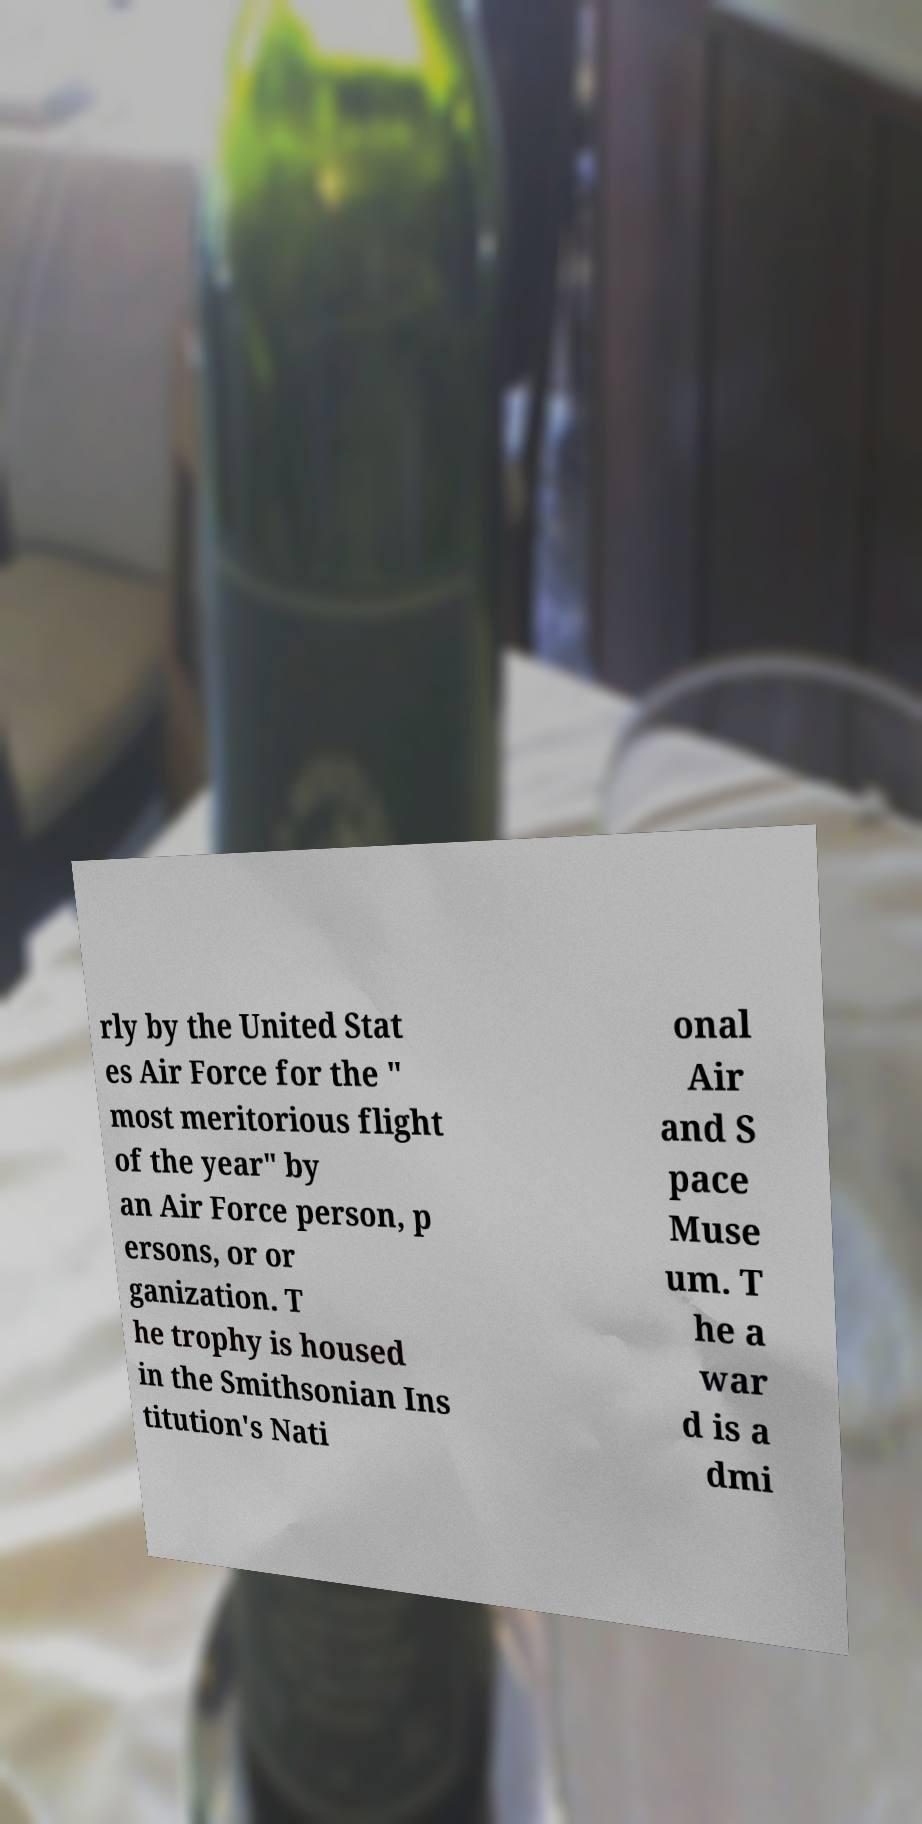Could you assist in decoding the text presented in this image and type it out clearly? rly by the United Stat es Air Force for the " most meritorious flight of the year" by an Air Force person, p ersons, or or ganization. T he trophy is housed in the Smithsonian Ins titution's Nati onal Air and S pace Muse um. T he a war d is a dmi 